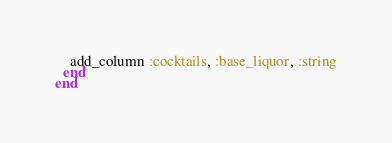Convert code to text. <code><loc_0><loc_0><loc_500><loc_500><_Ruby_>    add_column :cocktails, :base_liquor, :string
  end
end
</code> 